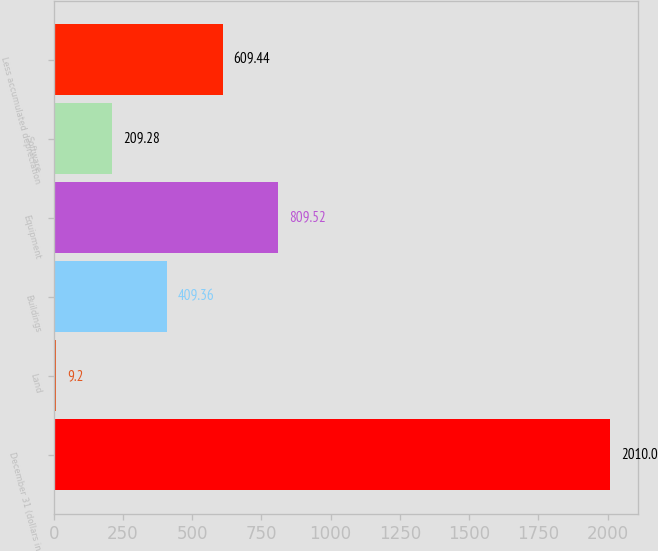Convert chart. <chart><loc_0><loc_0><loc_500><loc_500><bar_chart><fcel>December 31 (dollars in<fcel>Land<fcel>Buildings<fcel>Equipment<fcel>Software<fcel>Less accumulated depreciation<nl><fcel>2010<fcel>9.2<fcel>409.36<fcel>809.52<fcel>209.28<fcel>609.44<nl></chart> 